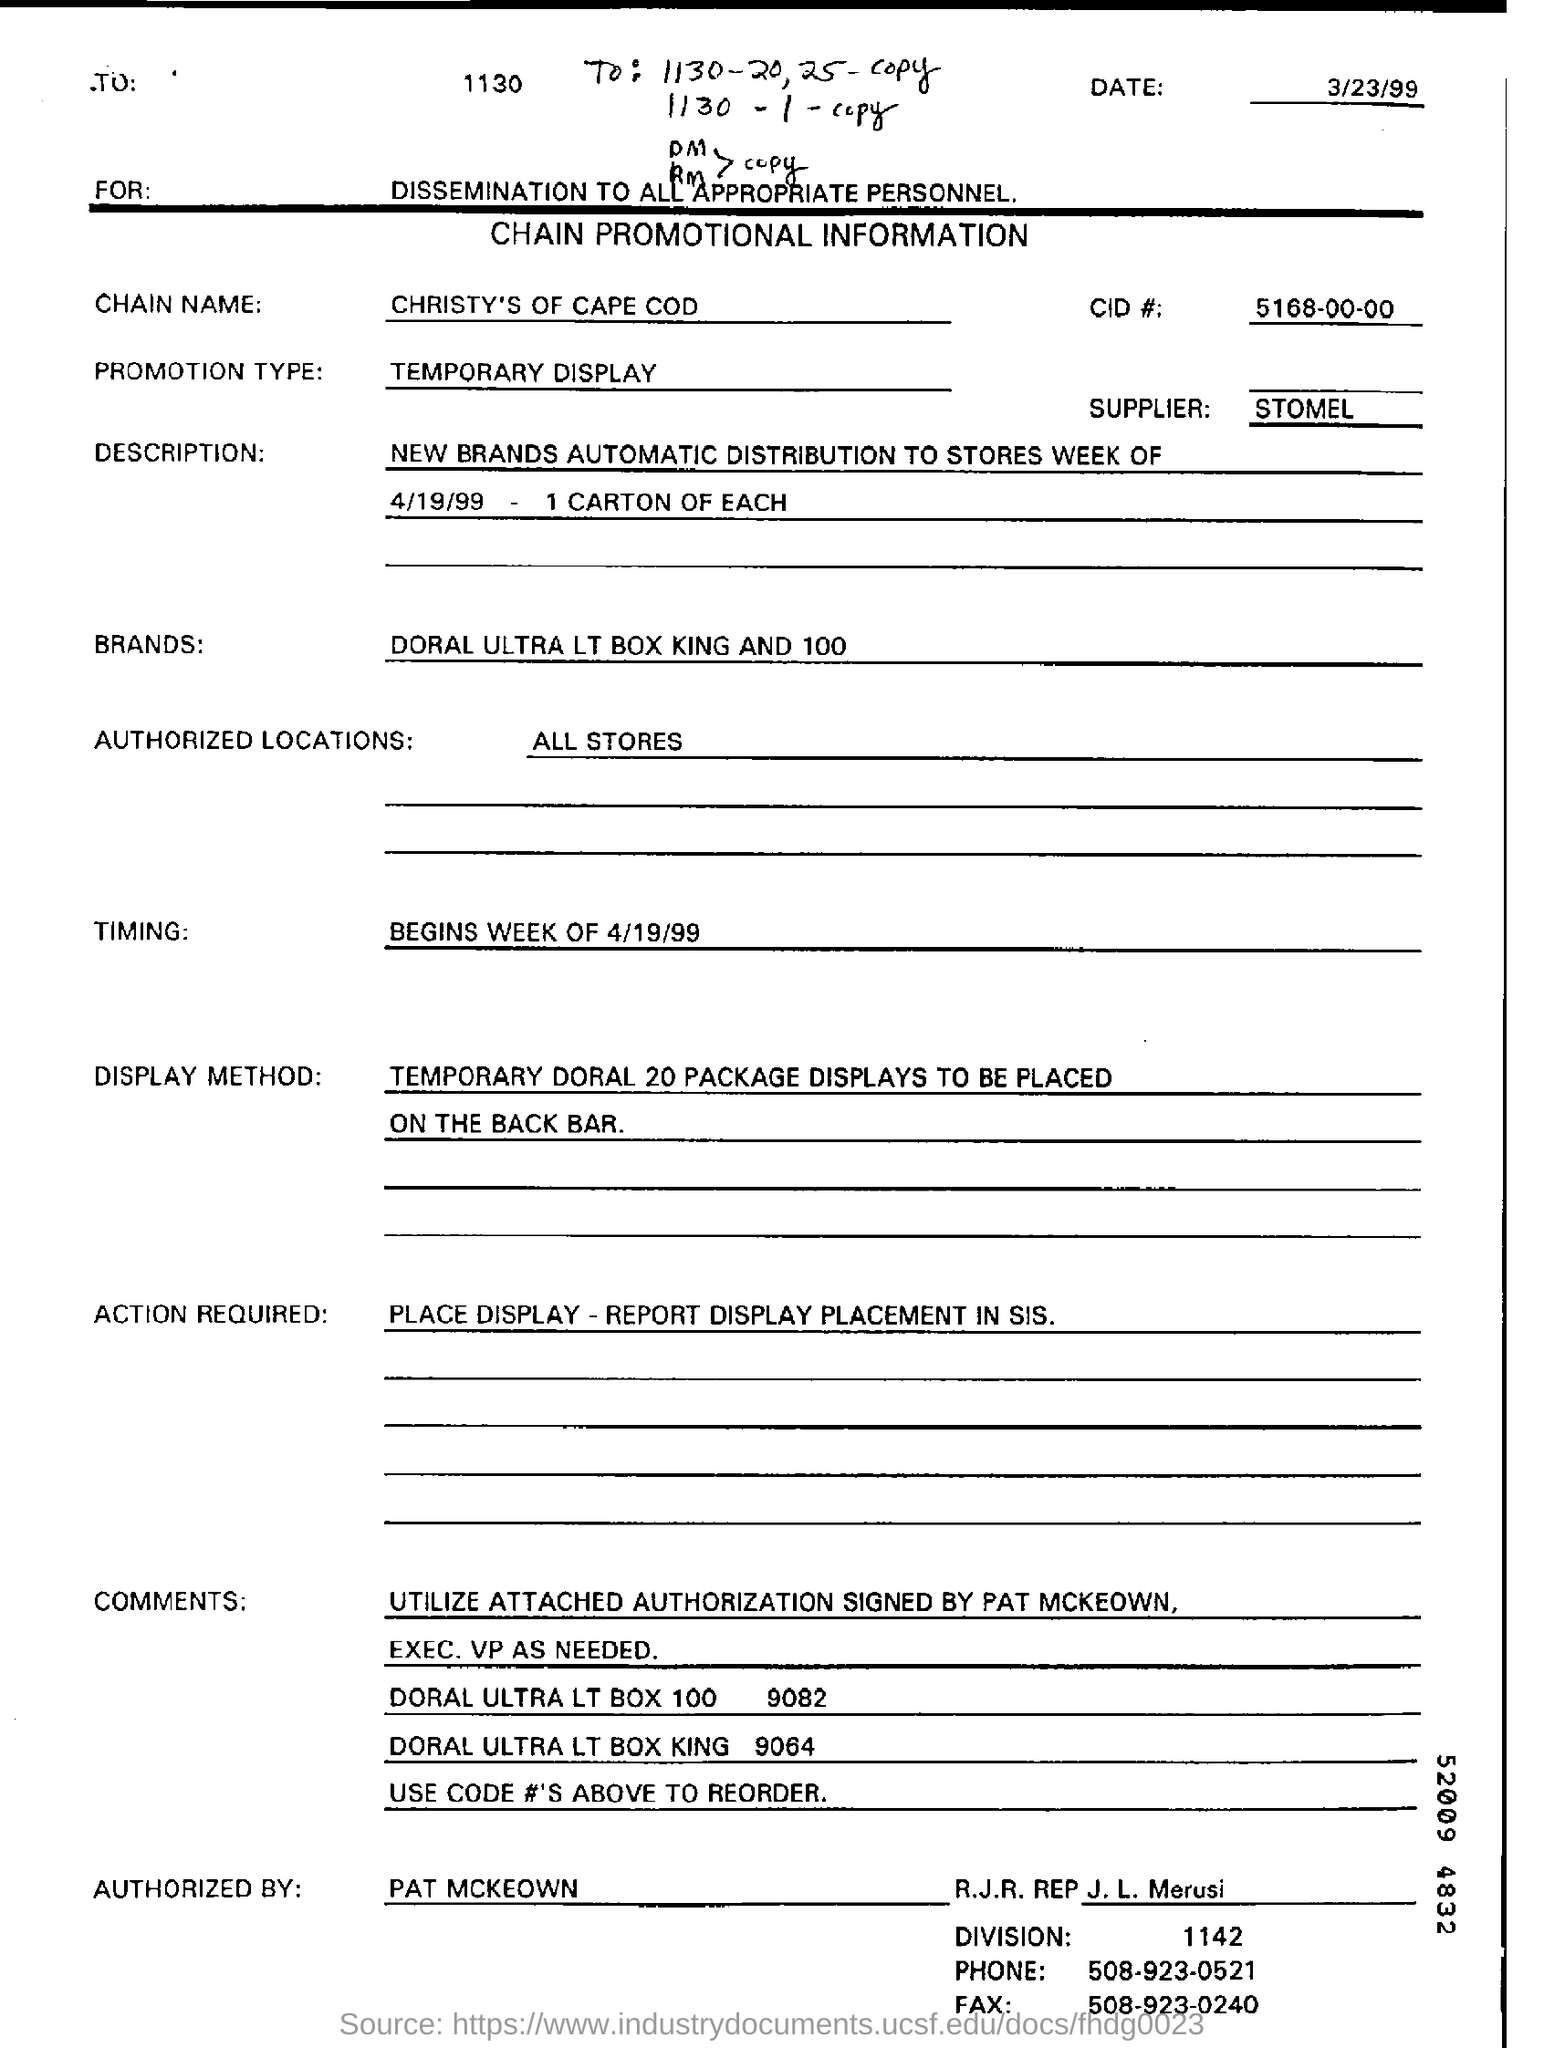Draw attention to some important aspects in this diagram. Christy's of Cape Cod is the name of the chain. This documentation is a chain promotional information. The document is dated as of March 23, 1999. The form is authorized by PAT MCKEOWN. The supplier is named STOMEL. 